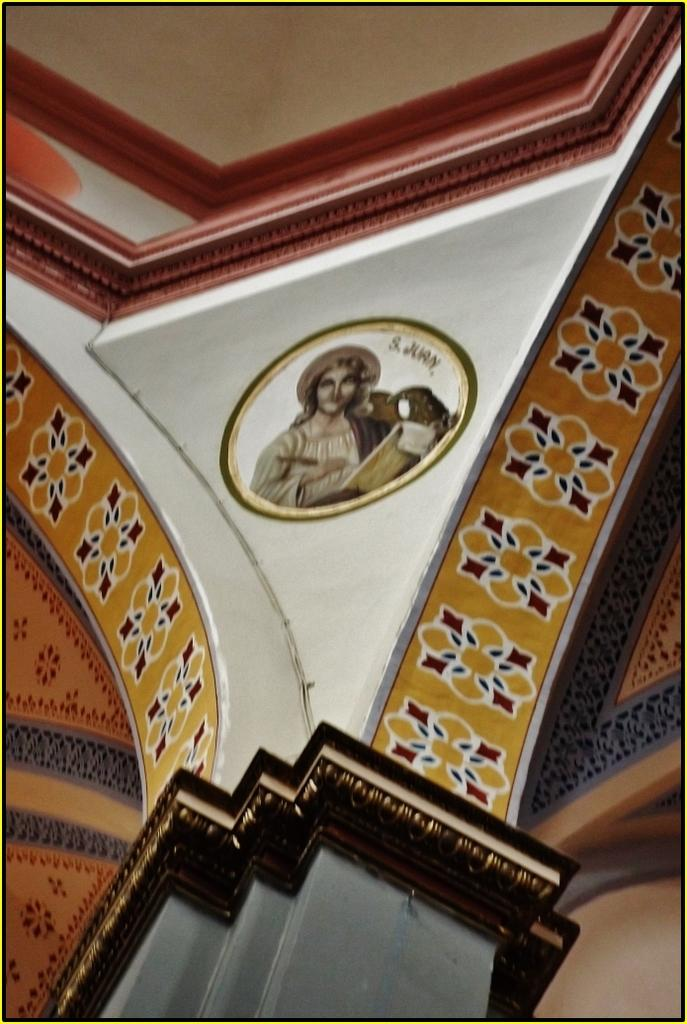What is the main structure visible in the image? There is a pillar in the image. Can you describe the pillar's appearance? The pillar has a design on it. What else can be seen in the image besides the pillar? There is a picture of a person in the image. What can be observed about the person in the picture? The person in the picture is wearing clothes. How many cats are sitting on the dinner table in the image? There are no cats or dinner table present in the image. What type of bat is flying near the person in the picture? There is no bat present in the image; it only features a pillar and a picture of a person. 